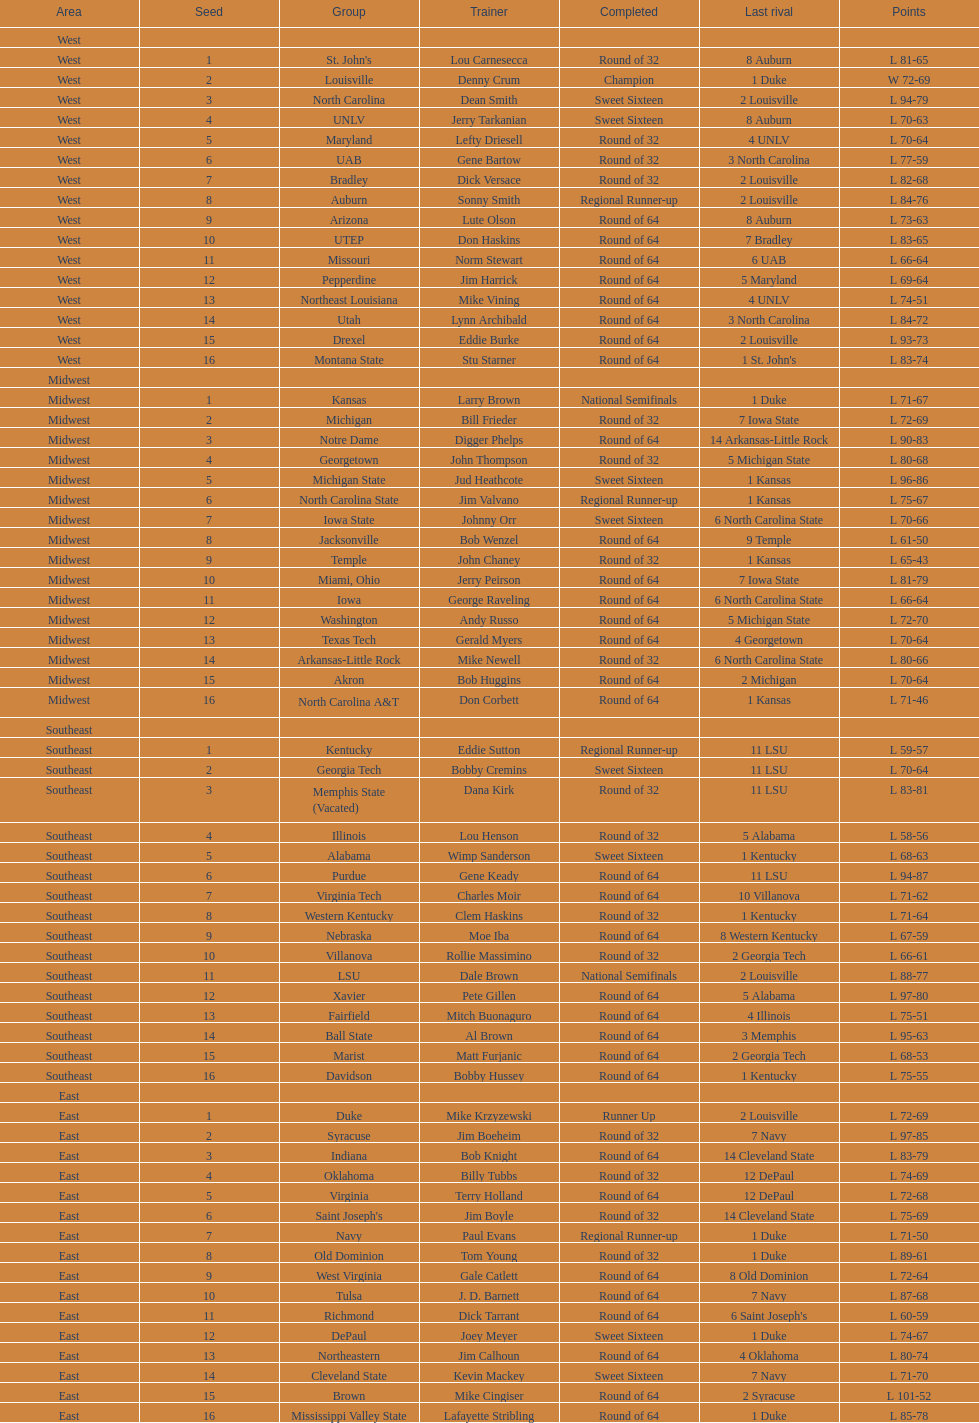How many 1 seeds are there? 4. 